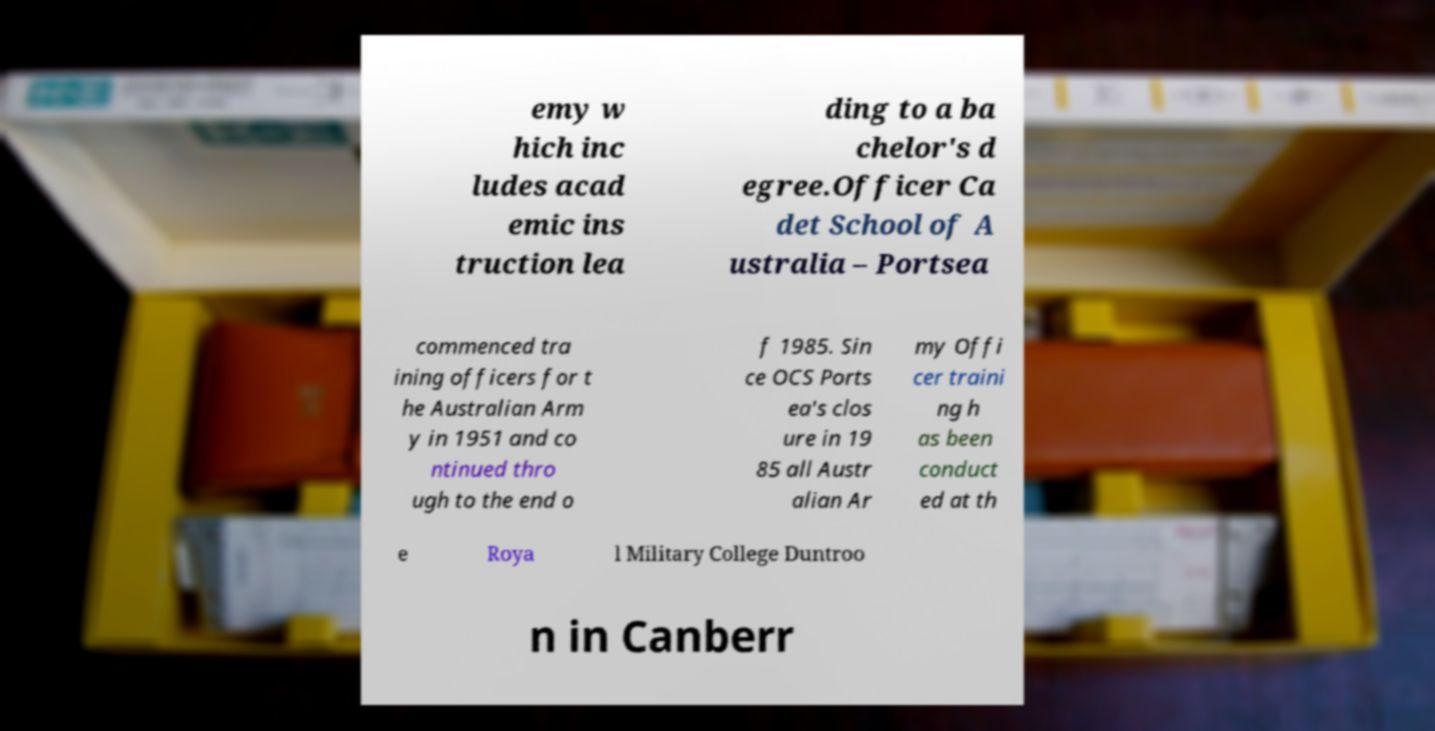Can you accurately transcribe the text from the provided image for me? emy w hich inc ludes acad emic ins truction lea ding to a ba chelor's d egree.Officer Ca det School of A ustralia – Portsea commenced tra ining officers for t he Australian Arm y in 1951 and co ntinued thro ugh to the end o f 1985. Sin ce OCS Ports ea's clos ure in 19 85 all Austr alian Ar my Offi cer traini ng h as been conduct ed at th e Roya l Military College Duntroo n in Canberr 